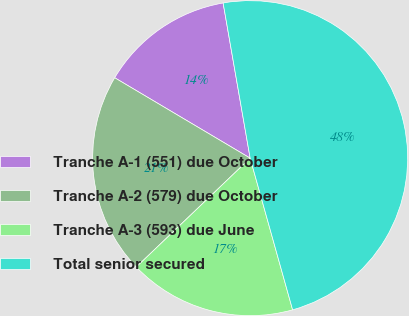Convert chart. <chart><loc_0><loc_0><loc_500><loc_500><pie_chart><fcel>Tranche A-1 (551) due October<fcel>Tranche A-2 (579) due October<fcel>Tranche A-3 (593) due June<fcel>Total senior secured<nl><fcel>13.73%<fcel>20.67%<fcel>17.2%<fcel>48.4%<nl></chart> 